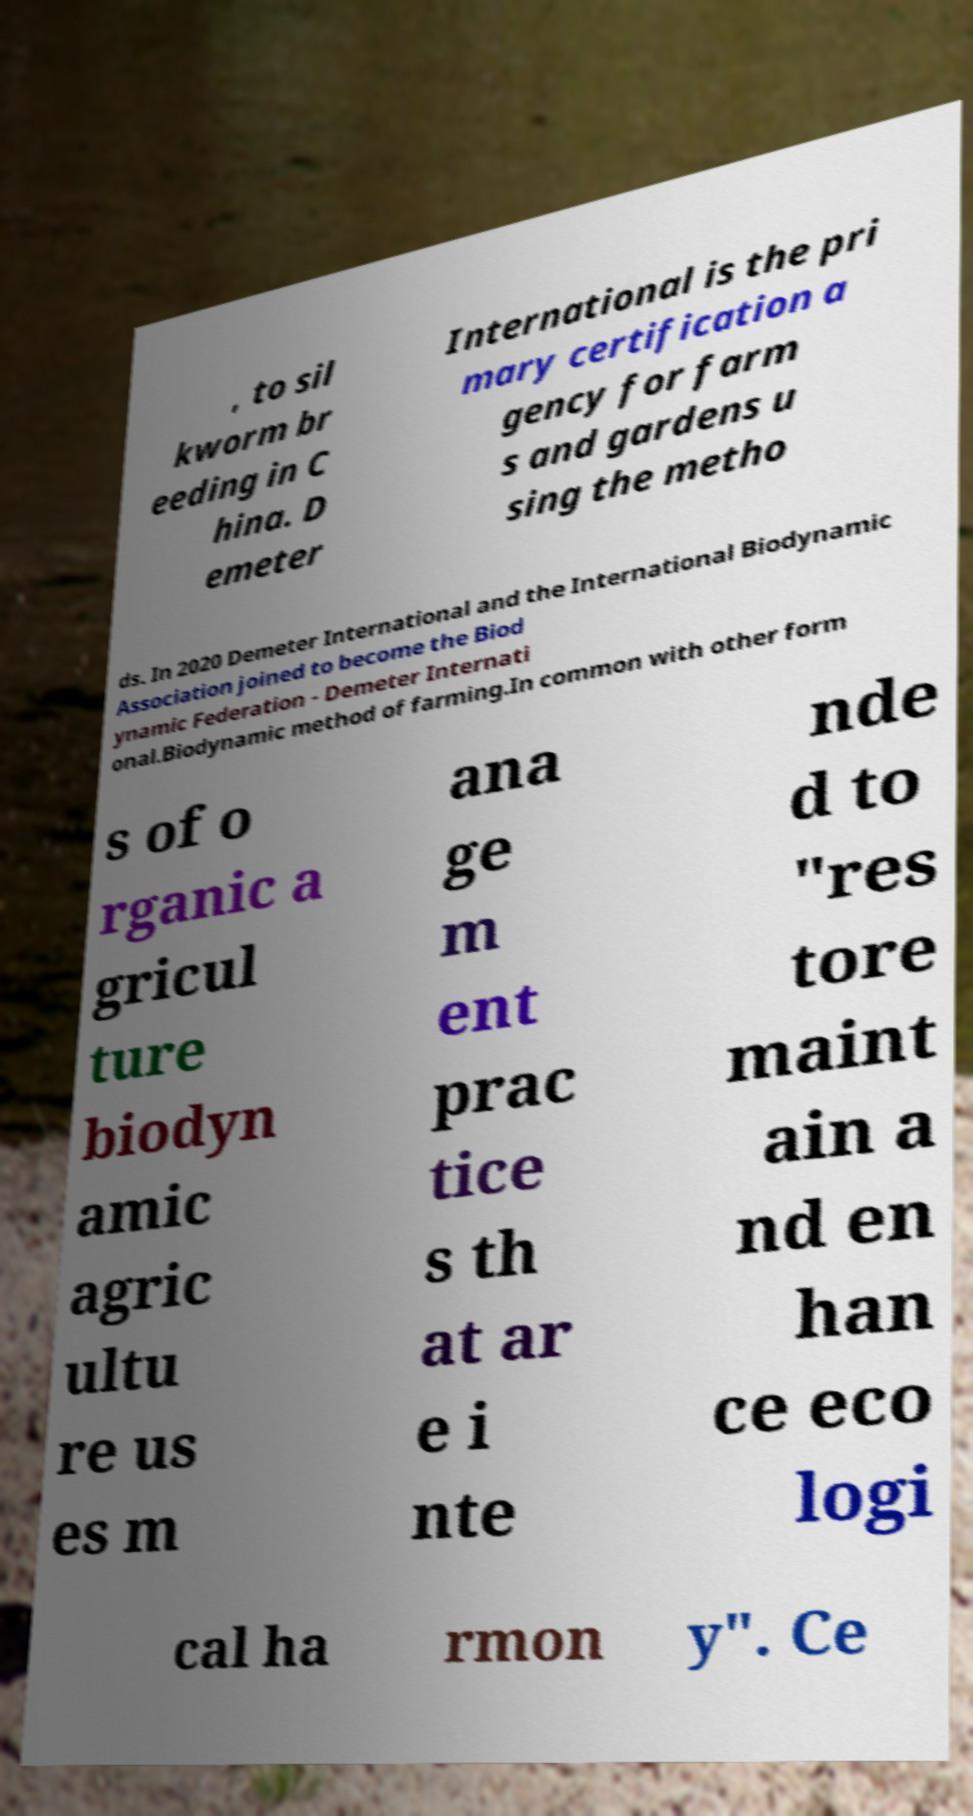What messages or text are displayed in this image? I need them in a readable, typed format. , to sil kworm br eeding in C hina. D emeter International is the pri mary certification a gency for farm s and gardens u sing the metho ds. In 2020 Demeter International and the International Biodynamic Association joined to become the Biod ynamic Federation - Demeter Internati onal.Biodynamic method of farming.In common with other form s of o rganic a gricul ture biodyn amic agric ultu re us es m ana ge m ent prac tice s th at ar e i nte nde d to "res tore maint ain a nd en han ce eco logi cal ha rmon y". Ce 